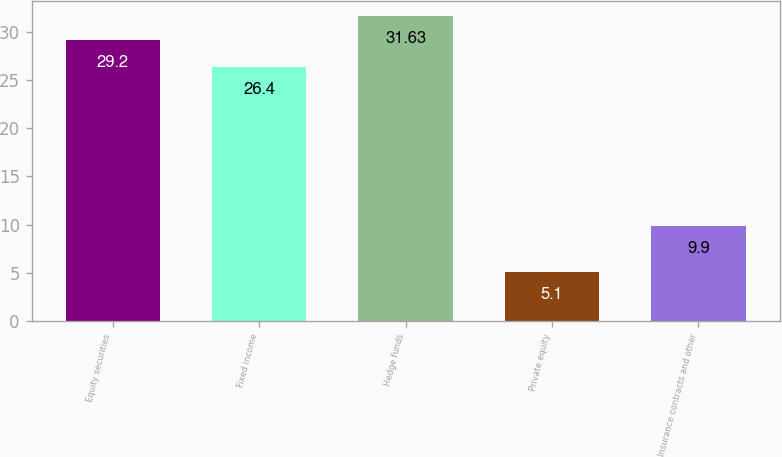Convert chart. <chart><loc_0><loc_0><loc_500><loc_500><bar_chart><fcel>Equity securities<fcel>Fixed income<fcel>Hedge funds<fcel>Private equity<fcel>Insurance contracts and other<nl><fcel>29.2<fcel>26.4<fcel>31.63<fcel>5.1<fcel>9.9<nl></chart> 